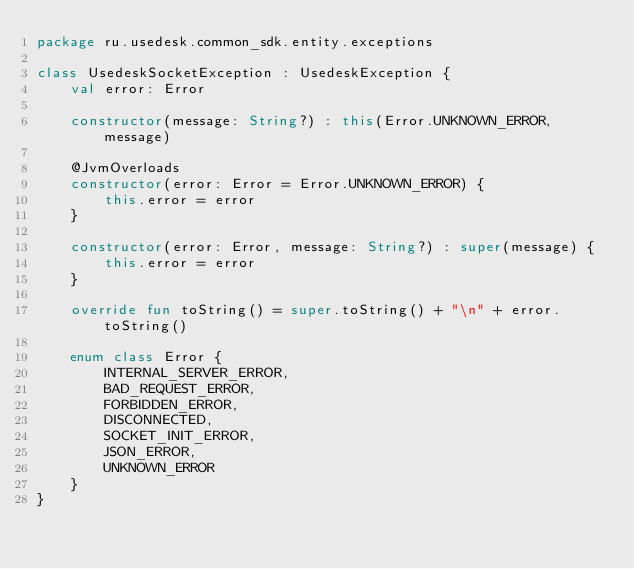Convert code to text. <code><loc_0><loc_0><loc_500><loc_500><_Kotlin_>package ru.usedesk.common_sdk.entity.exceptions

class UsedeskSocketException : UsedeskException {
    val error: Error

    constructor(message: String?) : this(Error.UNKNOWN_ERROR, message)

    @JvmOverloads
    constructor(error: Error = Error.UNKNOWN_ERROR) {
        this.error = error
    }

    constructor(error: Error, message: String?) : super(message) {
        this.error = error
    }

    override fun toString() = super.toString() + "\n" + error.toString()

    enum class Error {
        INTERNAL_SERVER_ERROR,
        BAD_REQUEST_ERROR,
        FORBIDDEN_ERROR,
        DISCONNECTED,
        SOCKET_INIT_ERROR,
        JSON_ERROR,
        UNKNOWN_ERROR
    }
}</code> 